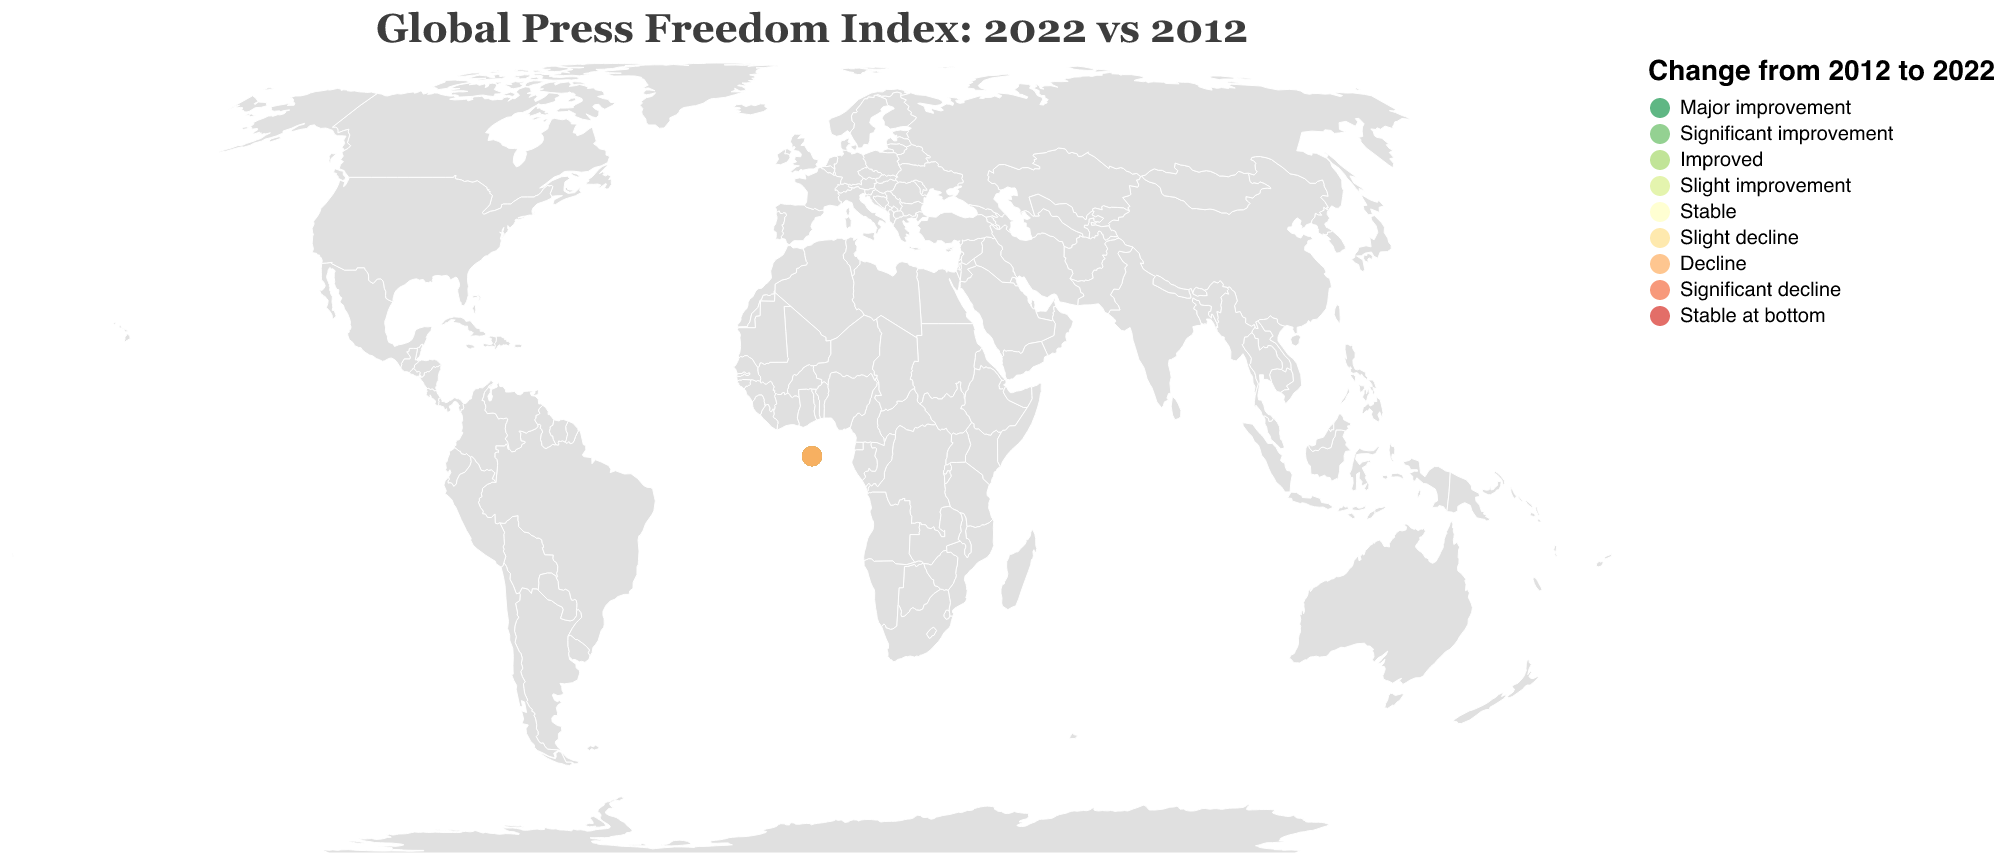What's the title of the figure? The title of the figure is typically displayed at the top of the chart. It reads "Global Press Freedom Index: 2022 vs 2012".
Answer: Global Press Freedom Index: 2022 vs 2012 Which country had the most significant improvement in press freedom ranked by an increase in positions? The figure uses colors to indicate notable changes, and Portugal shows a major improvement with its position moving from 33 in 2012 to 7 in 2022.
Answer: Portugal Which countries displayed a stable press freedom index without any notable changes? Looking at the colors representing 'Stable' in the legend and cross-referencing with the countries, Norway and Germany maintained their positions from 2012 to 2022.
Answer: Norway, Germany How did the United States' press freedom index change from 2012 to 2022? The tooltip information on the figure indicates that the United States improved slightly, moving from rank 47 in 2012 to rank 42 in 2022.
Answer: Slight improvement How does the press freedom index of Japan in 2022 compare to its index in 2012? By examining the tooltip or comparing the two indices directly, Japan's ranking dropped significantly from 22 in 2012 to 71 in 2022.
Answer: Significant decline Which country had the highest rank in press freedom in 2022? By observing the circles' tooltip information, Norway is ranked number 1 in 2022.
Answer: Norway List the countries that experienced a slight decline in press freedom index from 2012 to 2022. The notable changes are color-coded. By comparing the colors with the 'Slight decline' label, the countries are Sweden, Finland, Liechtenstein, China, and Australia.
Answer: Sweden, Finland, Liechtenstein, China, Australia Which countries showed a significant decline in press freedom over the past decade? The countries are color-coded with the 'Significant decline' hue. The notable changes listed include Japan, Russia, and India.
Answer: Japan, Russia, India Name the country that had a major improvement in press freedom from 2012 to 2022. According to the legend and tooltip, Portugal had a major improvement with its rank moving from 33 to 7.
Answer: Portugal Which country is at the bottom of the press freedom index in 2022? The tooltip information or visual marker at the end of the scale will reveal that North Korea is at the bottom, ranked 180.
Answer: North Korea 